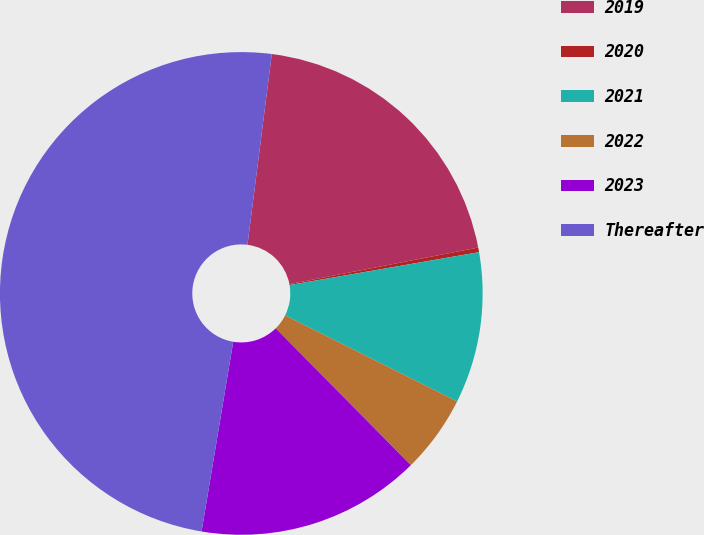<chart> <loc_0><loc_0><loc_500><loc_500><pie_chart><fcel>2019<fcel>2020<fcel>2021<fcel>2022<fcel>2023<fcel>Thereafter<nl><fcel>19.94%<fcel>0.31%<fcel>10.12%<fcel>5.22%<fcel>15.03%<fcel>49.39%<nl></chart> 